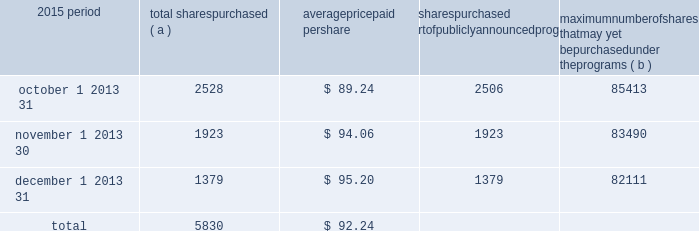We include here by reference additional information relating to pnc common stock under the common stock prices/ dividends declared section in the statistical information ( unaudited ) section of item 8 of this report .
We include here by reference the information regarding our compensation plans under which pnc equity securities are authorized for issuance as of december 31 , 2015 in the table ( with introductory paragraph and notes ) that appears under the caption 201capproval of 2016 incentive award plan 2013 item 3 201d in our proxy statement to be filed for the 2016 annual meeting of shareholders and is incorporated by reference herein and in item 12 of this report .
Our stock transfer agent and registrar is : computershare trust company , n.a .
250 royall street canton , ma 02021 800-982-7652 registered shareholders may contact the above phone number regarding dividends and other shareholder services .
We include here by reference the information that appears under the common stock performance graph caption at the end of this item 5 .
( a ) ( 2 ) none .
( b ) not applicable .
( c ) details of our repurchases of pnc common stock during the fourth quarter of 2015 are included in the table : in thousands , except per share data 2015 period total shares purchased ( a ) average paid per total shares purchased as part of publicly announced programs ( b ) maximum number of shares that may yet be purchased under the programs ( b ) .
( a ) includes pnc common stock purchased in connection with our various employee benefit plans generally related to forfeitures of unvested restricted stock awards and shares used to cover employee payroll tax withholding requirements .
Note 12 employee benefit plans and note 13 stock based compensation plans in the notes to consolidated financial statements in item 8 of this report include additional information regarding our employee benefit and equity compensation plans that use pnc common stock .
( b ) on march 11 , 2015 , we announced that our board of directors had approved the establishment of a new stock repurchase program authorization in the amount of 100 million shares of pnc common stock , effective april 1 , 2015 .
Repurchases are made in open market or privately negotiated transactions and the timing and exact amount of common stock repurchases will depend on a number of factors including , among others , market and general economic conditions , economic capital and regulatory capital considerations , alternative uses of capital , the potential impact on our credit ratings , and contractual and regulatory limitations , including the results of the supervisory assessment of capital adequacy and capital planning processes undertaken by the federal reserve as part of the ccar process .
Our 2015 capital plan , submitted as part of the ccar process and accepted by the federal reserve , included share repurchase programs of up to $ 2.875 billion for the five quarter period beginning with the second quarter of 2015 .
This amount does not include share repurchases in connection with various employee benefit plans referenced in note ( a ) .
In the fourth quarter of 2015 , in accordance with pnc 2019s 2015 capital plan and under the share repurchase authorization in effect during that period , we repurchased 5.8 million shares of common stock on the open market , with an average price of $ 92.26 per share and an aggregate repurchase price of $ .5 billion .
30 the pnc financial services group , inc .
2013 form 10-k .
Total shares purchased as part of publicly announced programs in the fourth quarter of 2015 totaled what? 
Computations: ((2506 + 1923) + 1379)
Answer: 5808.0. 